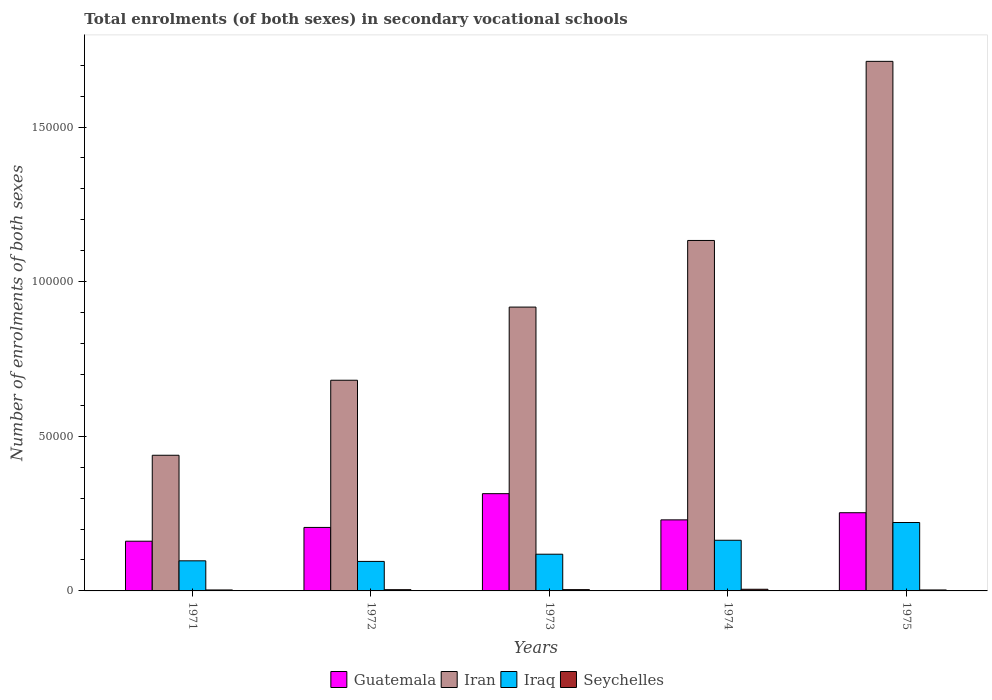How many different coloured bars are there?
Offer a terse response. 4. How many bars are there on the 5th tick from the right?
Your response must be concise. 4. What is the label of the 5th group of bars from the left?
Provide a short and direct response. 1975. What is the number of enrolments in secondary schools in Iran in 1975?
Your answer should be very brief. 1.71e+05. Across all years, what is the maximum number of enrolments in secondary schools in Seychelles?
Ensure brevity in your answer.  540. Across all years, what is the minimum number of enrolments in secondary schools in Guatemala?
Your response must be concise. 1.61e+04. In which year was the number of enrolments in secondary schools in Iran maximum?
Provide a succinct answer. 1975. What is the total number of enrolments in secondary schools in Guatemala in the graph?
Provide a short and direct response. 1.16e+05. What is the difference between the number of enrolments in secondary schools in Seychelles in 1972 and that in 1974?
Make the answer very short. -141. What is the difference between the number of enrolments in secondary schools in Iran in 1974 and the number of enrolments in secondary schools in Iraq in 1972?
Make the answer very short. 1.04e+05. What is the average number of enrolments in secondary schools in Guatemala per year?
Ensure brevity in your answer.  2.33e+04. In the year 1972, what is the difference between the number of enrolments in secondary schools in Iraq and number of enrolments in secondary schools in Iran?
Offer a very short reply. -5.86e+04. In how many years, is the number of enrolments in secondary schools in Iraq greater than 80000?
Offer a very short reply. 0. What is the ratio of the number of enrolments in secondary schools in Iraq in 1971 to that in 1973?
Your answer should be compact. 0.82. What is the difference between the highest and the second highest number of enrolments in secondary schools in Iran?
Provide a succinct answer. 5.79e+04. What is the difference between the highest and the lowest number of enrolments in secondary schools in Iraq?
Provide a succinct answer. 1.26e+04. In how many years, is the number of enrolments in secondary schools in Iraq greater than the average number of enrolments in secondary schools in Iraq taken over all years?
Ensure brevity in your answer.  2. Is it the case that in every year, the sum of the number of enrolments in secondary schools in Seychelles and number of enrolments in secondary schools in Iraq is greater than the sum of number of enrolments in secondary schools in Iran and number of enrolments in secondary schools in Guatemala?
Your answer should be very brief. No. What does the 4th bar from the left in 1971 represents?
Give a very brief answer. Seychelles. What does the 3rd bar from the right in 1974 represents?
Offer a terse response. Iran. What is the difference between two consecutive major ticks on the Y-axis?
Make the answer very short. 5.00e+04. Are the values on the major ticks of Y-axis written in scientific E-notation?
Offer a terse response. No. Where does the legend appear in the graph?
Provide a succinct answer. Bottom center. How are the legend labels stacked?
Provide a succinct answer. Horizontal. What is the title of the graph?
Ensure brevity in your answer.  Total enrolments (of both sexes) in secondary vocational schools. Does "Romania" appear as one of the legend labels in the graph?
Give a very brief answer. No. What is the label or title of the Y-axis?
Your answer should be compact. Number of enrolments of both sexes. What is the Number of enrolments of both sexes in Guatemala in 1971?
Your answer should be very brief. 1.61e+04. What is the Number of enrolments of both sexes in Iran in 1971?
Give a very brief answer. 4.39e+04. What is the Number of enrolments of both sexes of Iraq in 1971?
Give a very brief answer. 9732. What is the Number of enrolments of both sexes of Seychelles in 1971?
Make the answer very short. 312. What is the Number of enrolments of both sexes in Guatemala in 1972?
Give a very brief answer. 2.05e+04. What is the Number of enrolments of both sexes in Iran in 1972?
Offer a very short reply. 6.81e+04. What is the Number of enrolments of both sexes of Iraq in 1972?
Provide a succinct answer. 9543. What is the Number of enrolments of both sexes of Seychelles in 1972?
Provide a short and direct response. 399. What is the Number of enrolments of both sexes of Guatemala in 1973?
Ensure brevity in your answer.  3.14e+04. What is the Number of enrolments of both sexes in Iran in 1973?
Your answer should be very brief. 9.18e+04. What is the Number of enrolments of both sexes in Iraq in 1973?
Provide a succinct answer. 1.19e+04. What is the Number of enrolments of both sexes in Seychelles in 1973?
Your response must be concise. 418. What is the Number of enrolments of both sexes in Guatemala in 1974?
Offer a terse response. 2.30e+04. What is the Number of enrolments of both sexes in Iran in 1974?
Give a very brief answer. 1.13e+05. What is the Number of enrolments of both sexes in Iraq in 1974?
Provide a succinct answer. 1.64e+04. What is the Number of enrolments of both sexes of Seychelles in 1974?
Keep it short and to the point. 540. What is the Number of enrolments of both sexes of Guatemala in 1975?
Offer a very short reply. 2.53e+04. What is the Number of enrolments of both sexes in Iran in 1975?
Offer a very short reply. 1.71e+05. What is the Number of enrolments of both sexes of Iraq in 1975?
Offer a very short reply. 2.21e+04. What is the Number of enrolments of both sexes in Seychelles in 1975?
Keep it short and to the point. 313. Across all years, what is the maximum Number of enrolments of both sexes in Guatemala?
Ensure brevity in your answer.  3.14e+04. Across all years, what is the maximum Number of enrolments of both sexes in Iran?
Offer a very short reply. 1.71e+05. Across all years, what is the maximum Number of enrolments of both sexes in Iraq?
Give a very brief answer. 2.21e+04. Across all years, what is the maximum Number of enrolments of both sexes of Seychelles?
Your response must be concise. 540. Across all years, what is the minimum Number of enrolments of both sexes of Guatemala?
Your answer should be compact. 1.61e+04. Across all years, what is the minimum Number of enrolments of both sexes of Iran?
Offer a very short reply. 4.39e+04. Across all years, what is the minimum Number of enrolments of both sexes of Iraq?
Give a very brief answer. 9543. Across all years, what is the minimum Number of enrolments of both sexes of Seychelles?
Offer a terse response. 312. What is the total Number of enrolments of both sexes of Guatemala in the graph?
Your answer should be compact. 1.16e+05. What is the total Number of enrolments of both sexes in Iran in the graph?
Ensure brevity in your answer.  4.88e+05. What is the total Number of enrolments of both sexes in Iraq in the graph?
Offer a very short reply. 6.97e+04. What is the total Number of enrolments of both sexes of Seychelles in the graph?
Provide a short and direct response. 1982. What is the difference between the Number of enrolments of both sexes of Guatemala in 1971 and that in 1972?
Give a very brief answer. -4457. What is the difference between the Number of enrolments of both sexes of Iran in 1971 and that in 1972?
Ensure brevity in your answer.  -2.43e+04. What is the difference between the Number of enrolments of both sexes in Iraq in 1971 and that in 1972?
Give a very brief answer. 189. What is the difference between the Number of enrolments of both sexes in Seychelles in 1971 and that in 1972?
Your response must be concise. -87. What is the difference between the Number of enrolments of both sexes in Guatemala in 1971 and that in 1973?
Keep it short and to the point. -1.54e+04. What is the difference between the Number of enrolments of both sexes in Iran in 1971 and that in 1973?
Your answer should be very brief. -4.79e+04. What is the difference between the Number of enrolments of both sexes in Iraq in 1971 and that in 1973?
Your answer should be compact. -2140. What is the difference between the Number of enrolments of both sexes in Seychelles in 1971 and that in 1973?
Make the answer very short. -106. What is the difference between the Number of enrolments of both sexes in Guatemala in 1971 and that in 1974?
Your response must be concise. -6902. What is the difference between the Number of enrolments of both sexes of Iran in 1971 and that in 1974?
Your answer should be very brief. -6.95e+04. What is the difference between the Number of enrolments of both sexes of Iraq in 1971 and that in 1974?
Your answer should be very brief. -6650. What is the difference between the Number of enrolments of both sexes of Seychelles in 1971 and that in 1974?
Offer a very short reply. -228. What is the difference between the Number of enrolments of both sexes in Guatemala in 1971 and that in 1975?
Offer a terse response. -9210. What is the difference between the Number of enrolments of both sexes in Iran in 1971 and that in 1975?
Your response must be concise. -1.27e+05. What is the difference between the Number of enrolments of both sexes of Iraq in 1971 and that in 1975?
Offer a terse response. -1.24e+04. What is the difference between the Number of enrolments of both sexes in Guatemala in 1972 and that in 1973?
Your answer should be very brief. -1.09e+04. What is the difference between the Number of enrolments of both sexes in Iran in 1972 and that in 1973?
Offer a terse response. -2.37e+04. What is the difference between the Number of enrolments of both sexes in Iraq in 1972 and that in 1973?
Provide a short and direct response. -2329. What is the difference between the Number of enrolments of both sexes of Seychelles in 1972 and that in 1973?
Ensure brevity in your answer.  -19. What is the difference between the Number of enrolments of both sexes in Guatemala in 1972 and that in 1974?
Provide a succinct answer. -2445. What is the difference between the Number of enrolments of both sexes in Iran in 1972 and that in 1974?
Give a very brief answer. -4.52e+04. What is the difference between the Number of enrolments of both sexes of Iraq in 1972 and that in 1974?
Give a very brief answer. -6839. What is the difference between the Number of enrolments of both sexes of Seychelles in 1972 and that in 1974?
Your answer should be very brief. -141. What is the difference between the Number of enrolments of both sexes of Guatemala in 1972 and that in 1975?
Offer a very short reply. -4753. What is the difference between the Number of enrolments of both sexes in Iran in 1972 and that in 1975?
Provide a succinct answer. -1.03e+05. What is the difference between the Number of enrolments of both sexes of Iraq in 1972 and that in 1975?
Ensure brevity in your answer.  -1.26e+04. What is the difference between the Number of enrolments of both sexes of Seychelles in 1972 and that in 1975?
Give a very brief answer. 86. What is the difference between the Number of enrolments of both sexes in Guatemala in 1973 and that in 1974?
Provide a succinct answer. 8470. What is the difference between the Number of enrolments of both sexes of Iran in 1973 and that in 1974?
Your answer should be very brief. -2.15e+04. What is the difference between the Number of enrolments of both sexes of Iraq in 1973 and that in 1974?
Provide a succinct answer. -4510. What is the difference between the Number of enrolments of both sexes of Seychelles in 1973 and that in 1974?
Make the answer very short. -122. What is the difference between the Number of enrolments of both sexes of Guatemala in 1973 and that in 1975?
Offer a very short reply. 6162. What is the difference between the Number of enrolments of both sexes of Iran in 1973 and that in 1975?
Provide a succinct answer. -7.95e+04. What is the difference between the Number of enrolments of both sexes of Iraq in 1973 and that in 1975?
Your answer should be very brief. -1.02e+04. What is the difference between the Number of enrolments of both sexes of Seychelles in 1973 and that in 1975?
Provide a short and direct response. 105. What is the difference between the Number of enrolments of both sexes of Guatemala in 1974 and that in 1975?
Your answer should be very brief. -2308. What is the difference between the Number of enrolments of both sexes in Iran in 1974 and that in 1975?
Ensure brevity in your answer.  -5.79e+04. What is the difference between the Number of enrolments of both sexes of Iraq in 1974 and that in 1975?
Provide a short and direct response. -5740. What is the difference between the Number of enrolments of both sexes in Seychelles in 1974 and that in 1975?
Offer a very short reply. 227. What is the difference between the Number of enrolments of both sexes of Guatemala in 1971 and the Number of enrolments of both sexes of Iran in 1972?
Ensure brevity in your answer.  -5.21e+04. What is the difference between the Number of enrolments of both sexes of Guatemala in 1971 and the Number of enrolments of both sexes of Iraq in 1972?
Your response must be concise. 6533. What is the difference between the Number of enrolments of both sexes of Guatemala in 1971 and the Number of enrolments of both sexes of Seychelles in 1972?
Offer a very short reply. 1.57e+04. What is the difference between the Number of enrolments of both sexes in Iran in 1971 and the Number of enrolments of both sexes in Iraq in 1972?
Your answer should be very brief. 3.43e+04. What is the difference between the Number of enrolments of both sexes of Iran in 1971 and the Number of enrolments of both sexes of Seychelles in 1972?
Provide a succinct answer. 4.35e+04. What is the difference between the Number of enrolments of both sexes in Iraq in 1971 and the Number of enrolments of both sexes in Seychelles in 1972?
Provide a short and direct response. 9333. What is the difference between the Number of enrolments of both sexes of Guatemala in 1971 and the Number of enrolments of both sexes of Iran in 1973?
Give a very brief answer. -7.57e+04. What is the difference between the Number of enrolments of both sexes of Guatemala in 1971 and the Number of enrolments of both sexes of Iraq in 1973?
Offer a terse response. 4204. What is the difference between the Number of enrolments of both sexes in Guatemala in 1971 and the Number of enrolments of both sexes in Seychelles in 1973?
Offer a very short reply. 1.57e+04. What is the difference between the Number of enrolments of both sexes in Iran in 1971 and the Number of enrolments of both sexes in Iraq in 1973?
Give a very brief answer. 3.20e+04. What is the difference between the Number of enrolments of both sexes of Iran in 1971 and the Number of enrolments of both sexes of Seychelles in 1973?
Your response must be concise. 4.34e+04. What is the difference between the Number of enrolments of both sexes of Iraq in 1971 and the Number of enrolments of both sexes of Seychelles in 1973?
Your response must be concise. 9314. What is the difference between the Number of enrolments of both sexes in Guatemala in 1971 and the Number of enrolments of both sexes in Iran in 1974?
Provide a short and direct response. -9.72e+04. What is the difference between the Number of enrolments of both sexes of Guatemala in 1971 and the Number of enrolments of both sexes of Iraq in 1974?
Offer a very short reply. -306. What is the difference between the Number of enrolments of both sexes of Guatemala in 1971 and the Number of enrolments of both sexes of Seychelles in 1974?
Ensure brevity in your answer.  1.55e+04. What is the difference between the Number of enrolments of both sexes of Iran in 1971 and the Number of enrolments of both sexes of Iraq in 1974?
Your response must be concise. 2.75e+04. What is the difference between the Number of enrolments of both sexes in Iran in 1971 and the Number of enrolments of both sexes in Seychelles in 1974?
Keep it short and to the point. 4.33e+04. What is the difference between the Number of enrolments of both sexes of Iraq in 1971 and the Number of enrolments of both sexes of Seychelles in 1974?
Offer a terse response. 9192. What is the difference between the Number of enrolments of both sexes of Guatemala in 1971 and the Number of enrolments of both sexes of Iran in 1975?
Your answer should be compact. -1.55e+05. What is the difference between the Number of enrolments of both sexes in Guatemala in 1971 and the Number of enrolments of both sexes in Iraq in 1975?
Give a very brief answer. -6046. What is the difference between the Number of enrolments of both sexes in Guatemala in 1971 and the Number of enrolments of both sexes in Seychelles in 1975?
Your answer should be very brief. 1.58e+04. What is the difference between the Number of enrolments of both sexes of Iran in 1971 and the Number of enrolments of both sexes of Iraq in 1975?
Offer a very short reply. 2.17e+04. What is the difference between the Number of enrolments of both sexes in Iran in 1971 and the Number of enrolments of both sexes in Seychelles in 1975?
Give a very brief answer. 4.36e+04. What is the difference between the Number of enrolments of both sexes of Iraq in 1971 and the Number of enrolments of both sexes of Seychelles in 1975?
Give a very brief answer. 9419. What is the difference between the Number of enrolments of both sexes of Guatemala in 1972 and the Number of enrolments of both sexes of Iran in 1973?
Your response must be concise. -7.12e+04. What is the difference between the Number of enrolments of both sexes in Guatemala in 1972 and the Number of enrolments of both sexes in Iraq in 1973?
Ensure brevity in your answer.  8661. What is the difference between the Number of enrolments of both sexes in Guatemala in 1972 and the Number of enrolments of both sexes in Seychelles in 1973?
Provide a short and direct response. 2.01e+04. What is the difference between the Number of enrolments of both sexes in Iran in 1972 and the Number of enrolments of both sexes in Iraq in 1973?
Provide a short and direct response. 5.63e+04. What is the difference between the Number of enrolments of both sexes of Iran in 1972 and the Number of enrolments of both sexes of Seychelles in 1973?
Your response must be concise. 6.77e+04. What is the difference between the Number of enrolments of both sexes of Iraq in 1972 and the Number of enrolments of both sexes of Seychelles in 1973?
Keep it short and to the point. 9125. What is the difference between the Number of enrolments of both sexes in Guatemala in 1972 and the Number of enrolments of both sexes in Iran in 1974?
Give a very brief answer. -9.28e+04. What is the difference between the Number of enrolments of both sexes in Guatemala in 1972 and the Number of enrolments of both sexes in Iraq in 1974?
Offer a terse response. 4151. What is the difference between the Number of enrolments of both sexes in Guatemala in 1972 and the Number of enrolments of both sexes in Seychelles in 1974?
Ensure brevity in your answer.  2.00e+04. What is the difference between the Number of enrolments of both sexes in Iran in 1972 and the Number of enrolments of both sexes in Iraq in 1974?
Your answer should be compact. 5.17e+04. What is the difference between the Number of enrolments of both sexes in Iran in 1972 and the Number of enrolments of both sexes in Seychelles in 1974?
Make the answer very short. 6.76e+04. What is the difference between the Number of enrolments of both sexes of Iraq in 1972 and the Number of enrolments of both sexes of Seychelles in 1974?
Keep it short and to the point. 9003. What is the difference between the Number of enrolments of both sexes of Guatemala in 1972 and the Number of enrolments of both sexes of Iran in 1975?
Give a very brief answer. -1.51e+05. What is the difference between the Number of enrolments of both sexes in Guatemala in 1972 and the Number of enrolments of both sexes in Iraq in 1975?
Provide a short and direct response. -1589. What is the difference between the Number of enrolments of both sexes in Guatemala in 1972 and the Number of enrolments of both sexes in Seychelles in 1975?
Keep it short and to the point. 2.02e+04. What is the difference between the Number of enrolments of both sexes in Iran in 1972 and the Number of enrolments of both sexes in Iraq in 1975?
Your answer should be very brief. 4.60e+04. What is the difference between the Number of enrolments of both sexes of Iran in 1972 and the Number of enrolments of both sexes of Seychelles in 1975?
Provide a succinct answer. 6.78e+04. What is the difference between the Number of enrolments of both sexes in Iraq in 1972 and the Number of enrolments of both sexes in Seychelles in 1975?
Provide a short and direct response. 9230. What is the difference between the Number of enrolments of both sexes of Guatemala in 1973 and the Number of enrolments of both sexes of Iran in 1974?
Ensure brevity in your answer.  -8.19e+04. What is the difference between the Number of enrolments of both sexes of Guatemala in 1973 and the Number of enrolments of both sexes of Iraq in 1974?
Keep it short and to the point. 1.51e+04. What is the difference between the Number of enrolments of both sexes in Guatemala in 1973 and the Number of enrolments of both sexes in Seychelles in 1974?
Keep it short and to the point. 3.09e+04. What is the difference between the Number of enrolments of both sexes in Iran in 1973 and the Number of enrolments of both sexes in Iraq in 1974?
Give a very brief answer. 7.54e+04. What is the difference between the Number of enrolments of both sexes in Iran in 1973 and the Number of enrolments of both sexes in Seychelles in 1974?
Provide a short and direct response. 9.12e+04. What is the difference between the Number of enrolments of both sexes of Iraq in 1973 and the Number of enrolments of both sexes of Seychelles in 1974?
Ensure brevity in your answer.  1.13e+04. What is the difference between the Number of enrolments of both sexes in Guatemala in 1973 and the Number of enrolments of both sexes in Iran in 1975?
Ensure brevity in your answer.  -1.40e+05. What is the difference between the Number of enrolments of both sexes in Guatemala in 1973 and the Number of enrolments of both sexes in Iraq in 1975?
Keep it short and to the point. 9326. What is the difference between the Number of enrolments of both sexes in Guatemala in 1973 and the Number of enrolments of both sexes in Seychelles in 1975?
Your response must be concise. 3.11e+04. What is the difference between the Number of enrolments of both sexes in Iran in 1973 and the Number of enrolments of both sexes in Iraq in 1975?
Ensure brevity in your answer.  6.97e+04. What is the difference between the Number of enrolments of both sexes of Iran in 1973 and the Number of enrolments of both sexes of Seychelles in 1975?
Give a very brief answer. 9.15e+04. What is the difference between the Number of enrolments of both sexes in Iraq in 1973 and the Number of enrolments of both sexes in Seychelles in 1975?
Your answer should be very brief. 1.16e+04. What is the difference between the Number of enrolments of both sexes of Guatemala in 1974 and the Number of enrolments of both sexes of Iran in 1975?
Provide a short and direct response. -1.48e+05. What is the difference between the Number of enrolments of both sexes of Guatemala in 1974 and the Number of enrolments of both sexes of Iraq in 1975?
Offer a very short reply. 856. What is the difference between the Number of enrolments of both sexes of Guatemala in 1974 and the Number of enrolments of both sexes of Seychelles in 1975?
Keep it short and to the point. 2.27e+04. What is the difference between the Number of enrolments of both sexes in Iran in 1974 and the Number of enrolments of both sexes in Iraq in 1975?
Your answer should be compact. 9.12e+04. What is the difference between the Number of enrolments of both sexes of Iran in 1974 and the Number of enrolments of both sexes of Seychelles in 1975?
Offer a very short reply. 1.13e+05. What is the difference between the Number of enrolments of both sexes of Iraq in 1974 and the Number of enrolments of both sexes of Seychelles in 1975?
Your response must be concise. 1.61e+04. What is the average Number of enrolments of both sexes in Guatemala per year?
Ensure brevity in your answer.  2.33e+04. What is the average Number of enrolments of both sexes of Iran per year?
Ensure brevity in your answer.  9.77e+04. What is the average Number of enrolments of both sexes of Iraq per year?
Keep it short and to the point. 1.39e+04. What is the average Number of enrolments of both sexes of Seychelles per year?
Ensure brevity in your answer.  396.4. In the year 1971, what is the difference between the Number of enrolments of both sexes in Guatemala and Number of enrolments of both sexes in Iran?
Your answer should be compact. -2.78e+04. In the year 1971, what is the difference between the Number of enrolments of both sexes of Guatemala and Number of enrolments of both sexes of Iraq?
Your answer should be very brief. 6344. In the year 1971, what is the difference between the Number of enrolments of both sexes of Guatemala and Number of enrolments of both sexes of Seychelles?
Your response must be concise. 1.58e+04. In the year 1971, what is the difference between the Number of enrolments of both sexes in Iran and Number of enrolments of both sexes in Iraq?
Offer a very short reply. 3.41e+04. In the year 1971, what is the difference between the Number of enrolments of both sexes in Iran and Number of enrolments of both sexes in Seychelles?
Offer a terse response. 4.36e+04. In the year 1971, what is the difference between the Number of enrolments of both sexes in Iraq and Number of enrolments of both sexes in Seychelles?
Provide a short and direct response. 9420. In the year 1972, what is the difference between the Number of enrolments of both sexes in Guatemala and Number of enrolments of both sexes in Iran?
Make the answer very short. -4.76e+04. In the year 1972, what is the difference between the Number of enrolments of both sexes in Guatemala and Number of enrolments of both sexes in Iraq?
Offer a very short reply. 1.10e+04. In the year 1972, what is the difference between the Number of enrolments of both sexes in Guatemala and Number of enrolments of both sexes in Seychelles?
Offer a terse response. 2.01e+04. In the year 1972, what is the difference between the Number of enrolments of both sexes of Iran and Number of enrolments of both sexes of Iraq?
Your response must be concise. 5.86e+04. In the year 1972, what is the difference between the Number of enrolments of both sexes of Iran and Number of enrolments of both sexes of Seychelles?
Ensure brevity in your answer.  6.77e+04. In the year 1972, what is the difference between the Number of enrolments of both sexes in Iraq and Number of enrolments of both sexes in Seychelles?
Give a very brief answer. 9144. In the year 1973, what is the difference between the Number of enrolments of both sexes of Guatemala and Number of enrolments of both sexes of Iran?
Ensure brevity in your answer.  -6.03e+04. In the year 1973, what is the difference between the Number of enrolments of both sexes of Guatemala and Number of enrolments of both sexes of Iraq?
Provide a succinct answer. 1.96e+04. In the year 1973, what is the difference between the Number of enrolments of both sexes of Guatemala and Number of enrolments of both sexes of Seychelles?
Keep it short and to the point. 3.10e+04. In the year 1973, what is the difference between the Number of enrolments of both sexes of Iran and Number of enrolments of both sexes of Iraq?
Offer a very short reply. 7.99e+04. In the year 1973, what is the difference between the Number of enrolments of both sexes of Iran and Number of enrolments of both sexes of Seychelles?
Your answer should be very brief. 9.14e+04. In the year 1973, what is the difference between the Number of enrolments of both sexes in Iraq and Number of enrolments of both sexes in Seychelles?
Make the answer very short. 1.15e+04. In the year 1974, what is the difference between the Number of enrolments of both sexes of Guatemala and Number of enrolments of both sexes of Iran?
Your answer should be very brief. -9.03e+04. In the year 1974, what is the difference between the Number of enrolments of both sexes in Guatemala and Number of enrolments of both sexes in Iraq?
Make the answer very short. 6596. In the year 1974, what is the difference between the Number of enrolments of both sexes of Guatemala and Number of enrolments of both sexes of Seychelles?
Your response must be concise. 2.24e+04. In the year 1974, what is the difference between the Number of enrolments of both sexes of Iran and Number of enrolments of both sexes of Iraq?
Ensure brevity in your answer.  9.69e+04. In the year 1974, what is the difference between the Number of enrolments of both sexes of Iran and Number of enrolments of both sexes of Seychelles?
Your answer should be very brief. 1.13e+05. In the year 1974, what is the difference between the Number of enrolments of both sexes in Iraq and Number of enrolments of both sexes in Seychelles?
Ensure brevity in your answer.  1.58e+04. In the year 1975, what is the difference between the Number of enrolments of both sexes of Guatemala and Number of enrolments of both sexes of Iran?
Provide a succinct answer. -1.46e+05. In the year 1975, what is the difference between the Number of enrolments of both sexes in Guatemala and Number of enrolments of both sexes in Iraq?
Your answer should be very brief. 3164. In the year 1975, what is the difference between the Number of enrolments of both sexes of Guatemala and Number of enrolments of both sexes of Seychelles?
Give a very brief answer. 2.50e+04. In the year 1975, what is the difference between the Number of enrolments of both sexes in Iran and Number of enrolments of both sexes in Iraq?
Your answer should be compact. 1.49e+05. In the year 1975, what is the difference between the Number of enrolments of both sexes in Iran and Number of enrolments of both sexes in Seychelles?
Your answer should be very brief. 1.71e+05. In the year 1975, what is the difference between the Number of enrolments of both sexes in Iraq and Number of enrolments of both sexes in Seychelles?
Keep it short and to the point. 2.18e+04. What is the ratio of the Number of enrolments of both sexes of Guatemala in 1971 to that in 1972?
Provide a short and direct response. 0.78. What is the ratio of the Number of enrolments of both sexes of Iran in 1971 to that in 1972?
Offer a very short reply. 0.64. What is the ratio of the Number of enrolments of both sexes in Iraq in 1971 to that in 1972?
Make the answer very short. 1.02. What is the ratio of the Number of enrolments of both sexes in Seychelles in 1971 to that in 1972?
Give a very brief answer. 0.78. What is the ratio of the Number of enrolments of both sexes in Guatemala in 1971 to that in 1973?
Offer a terse response. 0.51. What is the ratio of the Number of enrolments of both sexes in Iran in 1971 to that in 1973?
Make the answer very short. 0.48. What is the ratio of the Number of enrolments of both sexes of Iraq in 1971 to that in 1973?
Give a very brief answer. 0.82. What is the ratio of the Number of enrolments of both sexes of Seychelles in 1971 to that in 1973?
Ensure brevity in your answer.  0.75. What is the ratio of the Number of enrolments of both sexes in Guatemala in 1971 to that in 1974?
Provide a succinct answer. 0.7. What is the ratio of the Number of enrolments of both sexes of Iran in 1971 to that in 1974?
Offer a very short reply. 0.39. What is the ratio of the Number of enrolments of both sexes of Iraq in 1971 to that in 1974?
Your answer should be compact. 0.59. What is the ratio of the Number of enrolments of both sexes in Seychelles in 1971 to that in 1974?
Your response must be concise. 0.58. What is the ratio of the Number of enrolments of both sexes in Guatemala in 1971 to that in 1975?
Your response must be concise. 0.64. What is the ratio of the Number of enrolments of both sexes in Iran in 1971 to that in 1975?
Offer a terse response. 0.26. What is the ratio of the Number of enrolments of both sexes of Iraq in 1971 to that in 1975?
Provide a short and direct response. 0.44. What is the ratio of the Number of enrolments of both sexes in Seychelles in 1971 to that in 1975?
Offer a very short reply. 1. What is the ratio of the Number of enrolments of both sexes in Guatemala in 1972 to that in 1973?
Give a very brief answer. 0.65. What is the ratio of the Number of enrolments of both sexes in Iran in 1972 to that in 1973?
Your response must be concise. 0.74. What is the ratio of the Number of enrolments of both sexes in Iraq in 1972 to that in 1973?
Ensure brevity in your answer.  0.8. What is the ratio of the Number of enrolments of both sexes of Seychelles in 1972 to that in 1973?
Give a very brief answer. 0.95. What is the ratio of the Number of enrolments of both sexes of Guatemala in 1972 to that in 1974?
Offer a terse response. 0.89. What is the ratio of the Number of enrolments of both sexes in Iran in 1972 to that in 1974?
Provide a short and direct response. 0.6. What is the ratio of the Number of enrolments of both sexes in Iraq in 1972 to that in 1974?
Your answer should be compact. 0.58. What is the ratio of the Number of enrolments of both sexes of Seychelles in 1972 to that in 1974?
Ensure brevity in your answer.  0.74. What is the ratio of the Number of enrolments of both sexes of Guatemala in 1972 to that in 1975?
Your answer should be compact. 0.81. What is the ratio of the Number of enrolments of both sexes of Iran in 1972 to that in 1975?
Make the answer very short. 0.4. What is the ratio of the Number of enrolments of both sexes in Iraq in 1972 to that in 1975?
Offer a very short reply. 0.43. What is the ratio of the Number of enrolments of both sexes of Seychelles in 1972 to that in 1975?
Offer a very short reply. 1.27. What is the ratio of the Number of enrolments of both sexes in Guatemala in 1973 to that in 1974?
Your response must be concise. 1.37. What is the ratio of the Number of enrolments of both sexes of Iran in 1973 to that in 1974?
Keep it short and to the point. 0.81. What is the ratio of the Number of enrolments of both sexes of Iraq in 1973 to that in 1974?
Give a very brief answer. 0.72. What is the ratio of the Number of enrolments of both sexes of Seychelles in 1973 to that in 1974?
Your answer should be compact. 0.77. What is the ratio of the Number of enrolments of both sexes of Guatemala in 1973 to that in 1975?
Offer a terse response. 1.24. What is the ratio of the Number of enrolments of both sexes of Iran in 1973 to that in 1975?
Offer a very short reply. 0.54. What is the ratio of the Number of enrolments of both sexes in Iraq in 1973 to that in 1975?
Offer a very short reply. 0.54. What is the ratio of the Number of enrolments of both sexes of Seychelles in 1973 to that in 1975?
Keep it short and to the point. 1.34. What is the ratio of the Number of enrolments of both sexes of Guatemala in 1974 to that in 1975?
Give a very brief answer. 0.91. What is the ratio of the Number of enrolments of both sexes in Iran in 1974 to that in 1975?
Offer a terse response. 0.66. What is the ratio of the Number of enrolments of both sexes in Iraq in 1974 to that in 1975?
Keep it short and to the point. 0.74. What is the ratio of the Number of enrolments of both sexes of Seychelles in 1974 to that in 1975?
Provide a succinct answer. 1.73. What is the difference between the highest and the second highest Number of enrolments of both sexes in Guatemala?
Your answer should be very brief. 6162. What is the difference between the highest and the second highest Number of enrolments of both sexes in Iran?
Your answer should be very brief. 5.79e+04. What is the difference between the highest and the second highest Number of enrolments of both sexes in Iraq?
Offer a very short reply. 5740. What is the difference between the highest and the second highest Number of enrolments of both sexes of Seychelles?
Keep it short and to the point. 122. What is the difference between the highest and the lowest Number of enrolments of both sexes in Guatemala?
Your answer should be compact. 1.54e+04. What is the difference between the highest and the lowest Number of enrolments of both sexes in Iran?
Your answer should be very brief. 1.27e+05. What is the difference between the highest and the lowest Number of enrolments of both sexes in Iraq?
Keep it short and to the point. 1.26e+04. What is the difference between the highest and the lowest Number of enrolments of both sexes in Seychelles?
Your answer should be very brief. 228. 